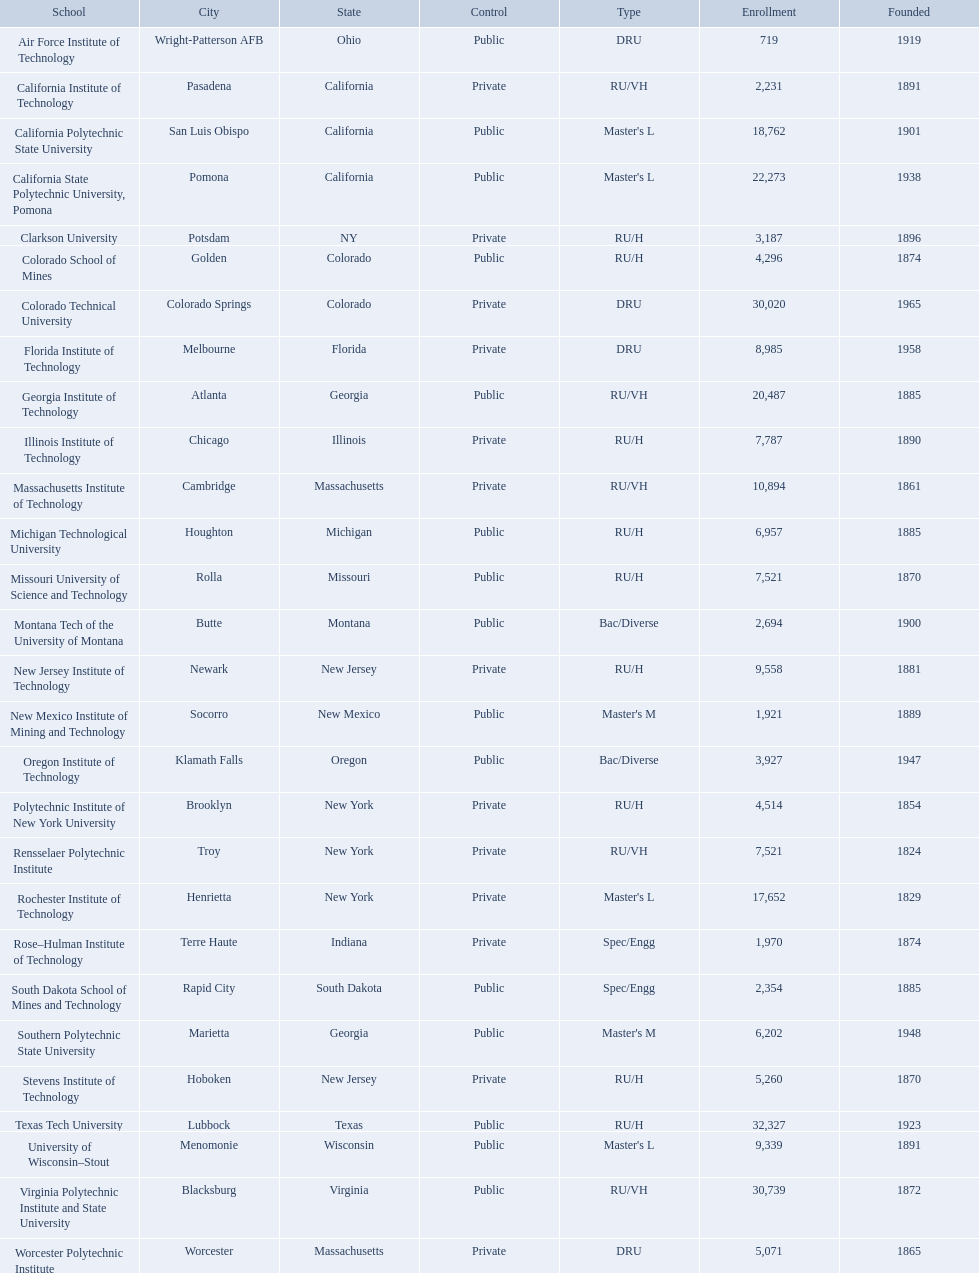What are the listed enrollment numbers of us universities? 719, 2,231, 18,762, 22,273, 3,187, 4,296, 30,020, 8,985, 20,487, 7,787, 10,894, 6,957, 7,521, 2,694, 9,558, 1,921, 3,927, 4,514, 7,521, 17,652, 1,970, 2,354, 6,202, 5,260, 32,327, 9,339, 30,739, 5,071. Of these, which has the highest value? 32,327. What are the listed names of us universities? Air Force Institute of Technology, California Institute of Technology, California Polytechnic State University, California State Polytechnic University, Pomona, Clarkson University, Colorado School of Mines, Colorado Technical University, Florida Institute of Technology, Georgia Institute of Technology, Illinois Institute of Technology, Massachusetts Institute of Technology, Michigan Technological University, Missouri University of Science and Technology, Montana Tech of the University of Montana, New Jersey Institute of Technology, New Mexico Institute of Mining and Technology, Oregon Institute of Technology, Polytechnic Institute of New York University, Rensselaer Polytechnic Institute, Rochester Institute of Technology, Rose–Hulman Institute of Technology, South Dakota School of Mines and Technology, Southern Polytechnic State University, Stevens Institute of Technology, Texas Tech University, University of Wisconsin–Stout, Virginia Polytechnic Institute and State University, Worcester Polytechnic Institute. Which of these correspond to the previously listed highest enrollment value? Texas Tech University. 